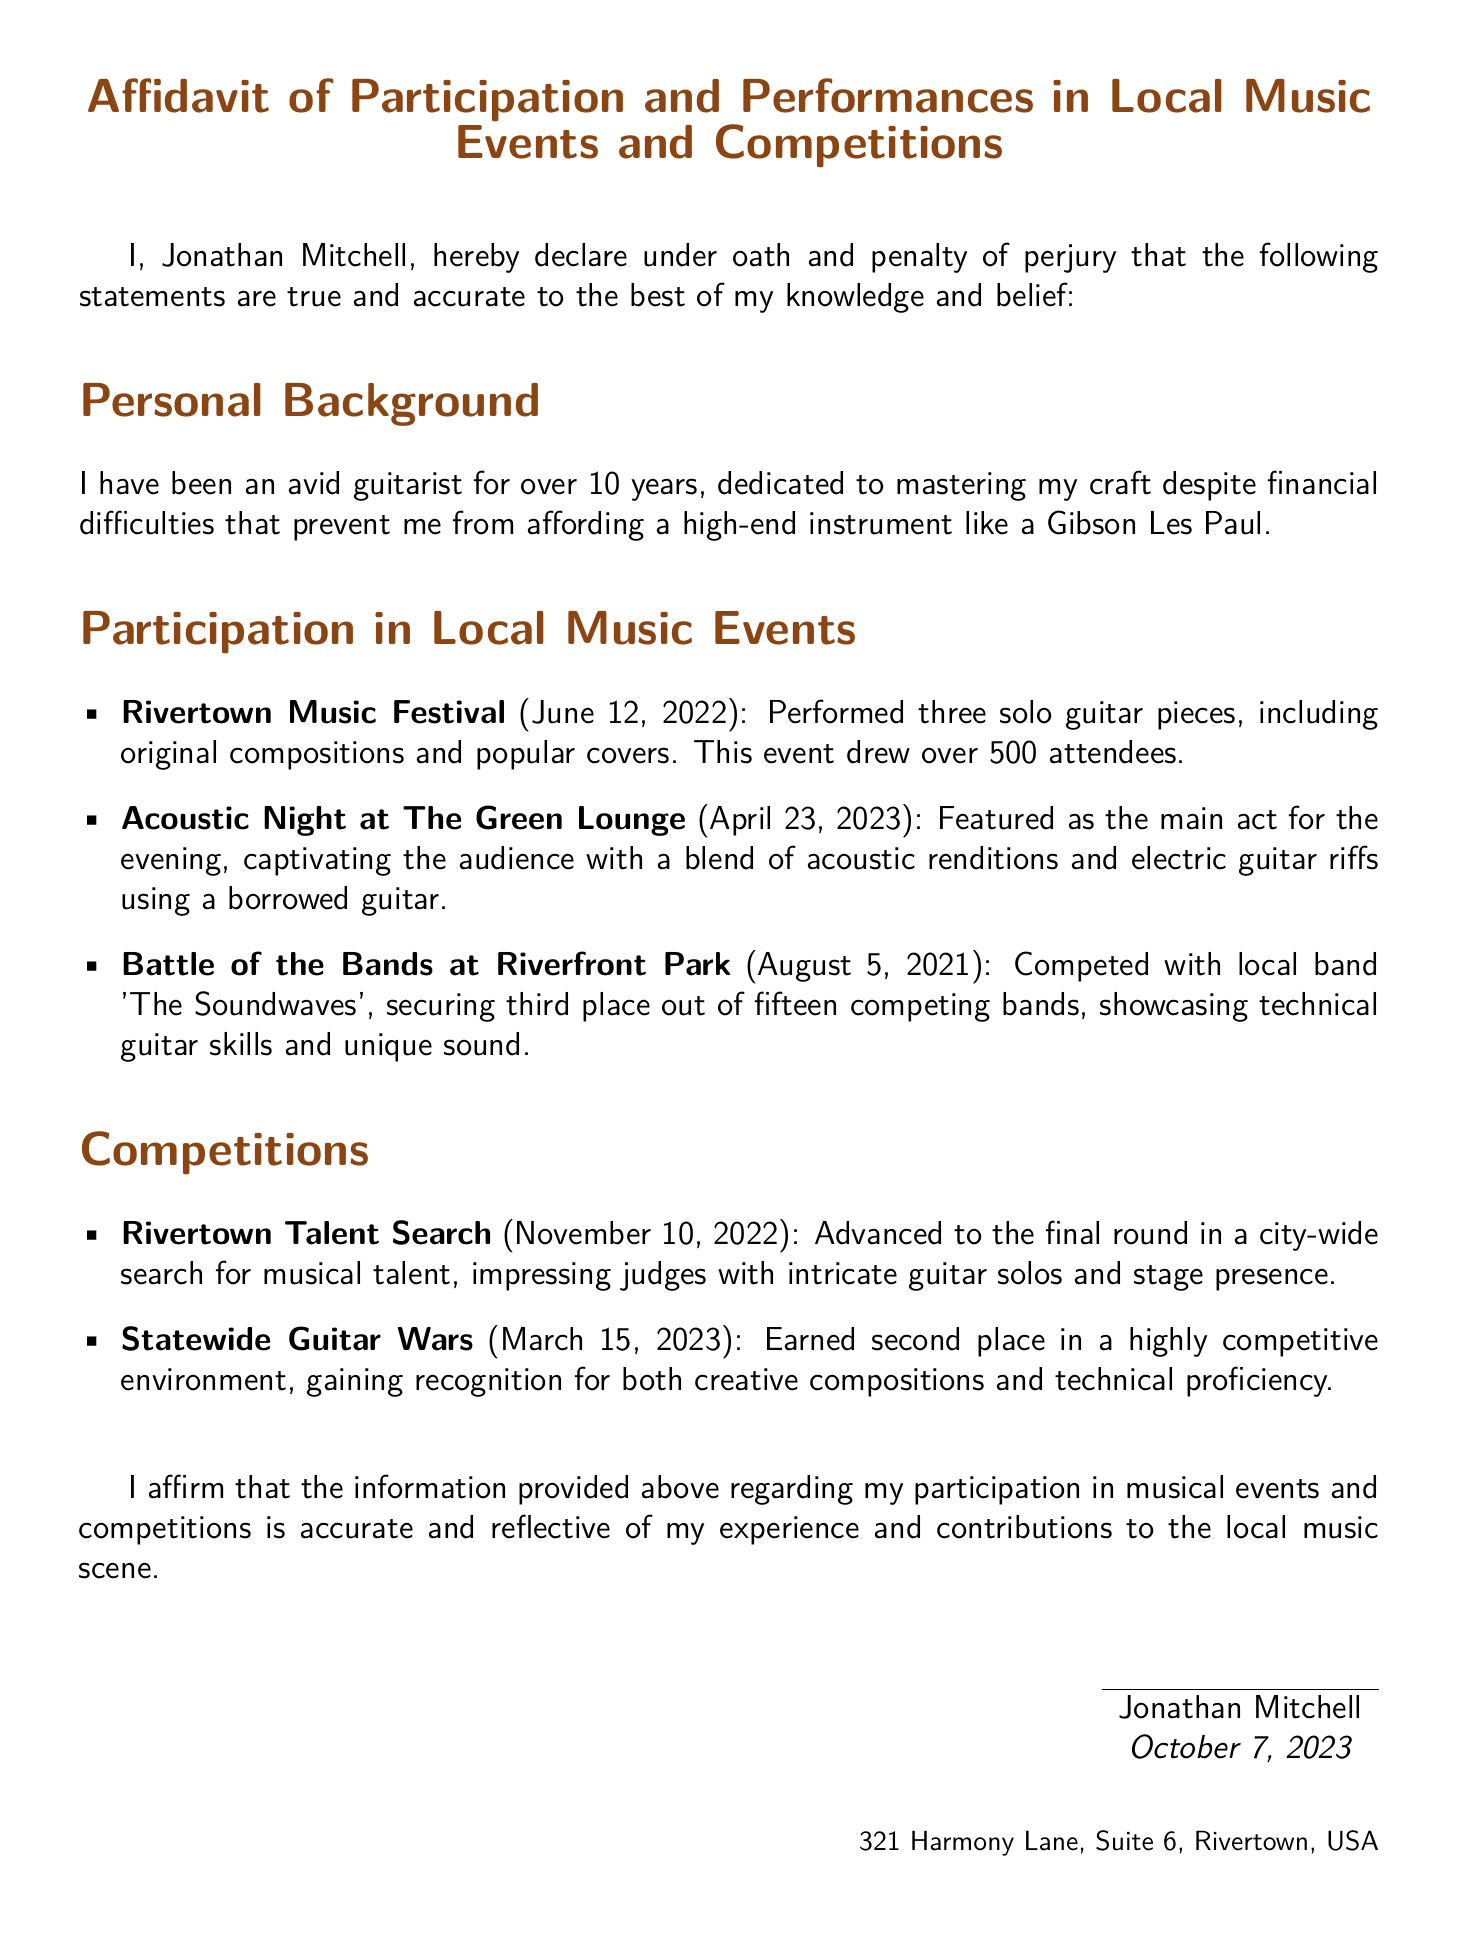What is the full name of the person who signed the affidavit? The document states the signer's full name as Jonathan Mitchell.
Answer: Jonathan Mitchell What competition did Jonathan participate in on March 15, 2023? The document lists the competition as Statewide Guitar Wars.
Answer: Statewide Guitar Wars What place did Jonathan secure in the Battle of the Bands at Riverfront Park? The document mentions that Jonathan secured third place out of fifteen bands in that competition.
Answer: Third place When did the Rivertown Music Festival take place? The document states that the festival occurred on June 12, 2022.
Answer: June 12, 2022 How many solo guitar pieces did Jonathan perform at the Rivertown Music Festival? The document indicates that he performed three solo guitar pieces at the festival.
Answer: Three What type of venue hosted Acoustic Night where Jonathan performed? The document refers to the venue as The Green Lounge.
Answer: The Green Lounge What did Jonathan use for playing at Acoustic Night? The document states that he used a borrowed guitar for his performance.
Answer: Borrowed guitar How long has Jonathan been playing the guitar? The document states that he has been playing for over 10 years.
Answer: Over 10 years 